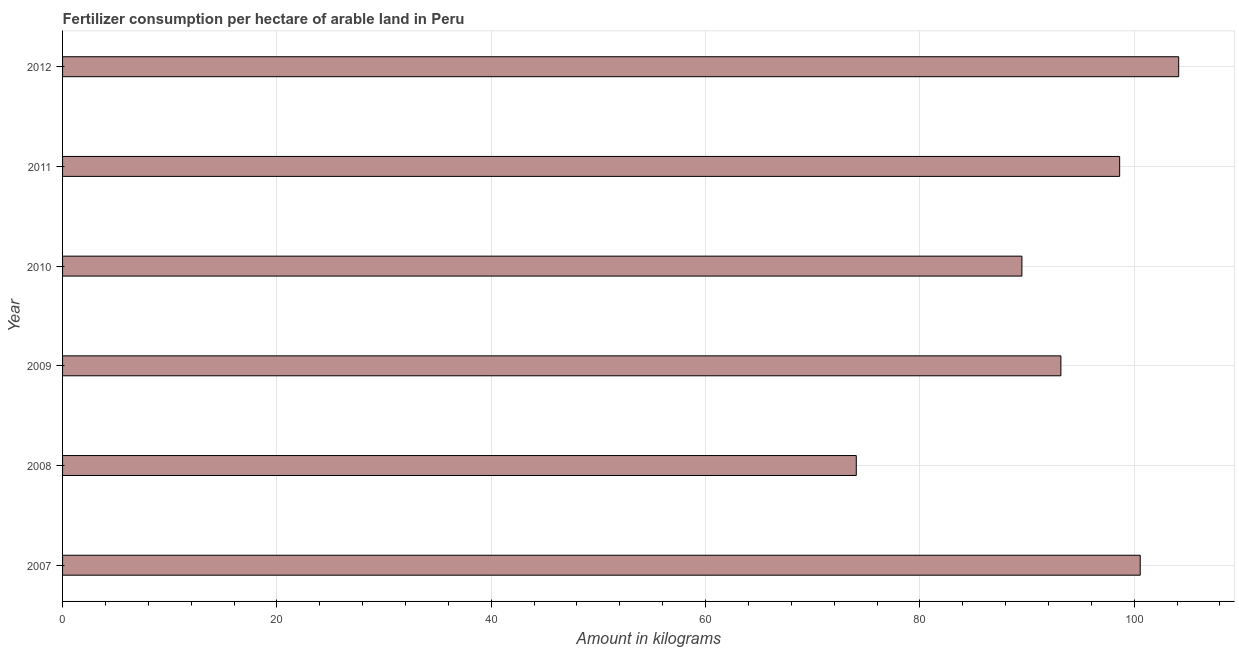Does the graph contain any zero values?
Offer a very short reply. No. Does the graph contain grids?
Offer a terse response. Yes. What is the title of the graph?
Ensure brevity in your answer.  Fertilizer consumption per hectare of arable land in Peru . What is the label or title of the X-axis?
Provide a succinct answer. Amount in kilograms. What is the amount of fertilizer consumption in 2011?
Offer a very short reply. 98.64. Across all years, what is the maximum amount of fertilizer consumption?
Your answer should be very brief. 104.15. Across all years, what is the minimum amount of fertilizer consumption?
Make the answer very short. 74.07. In which year was the amount of fertilizer consumption minimum?
Provide a succinct answer. 2008. What is the sum of the amount of fertilizer consumption?
Give a very brief answer. 560.1. What is the difference between the amount of fertilizer consumption in 2008 and 2010?
Offer a terse response. -15.46. What is the average amount of fertilizer consumption per year?
Your response must be concise. 93.35. What is the median amount of fertilizer consumption?
Ensure brevity in your answer.  95.9. What is the ratio of the amount of fertilizer consumption in 2008 to that in 2010?
Keep it short and to the point. 0.83. Is the amount of fertilizer consumption in 2010 less than that in 2011?
Your response must be concise. Yes. Is the difference between the amount of fertilizer consumption in 2008 and 2012 greater than the difference between any two years?
Your response must be concise. Yes. What is the difference between the highest and the second highest amount of fertilizer consumption?
Give a very brief answer. 3.59. What is the difference between the highest and the lowest amount of fertilizer consumption?
Your answer should be very brief. 30.09. In how many years, is the amount of fertilizer consumption greater than the average amount of fertilizer consumption taken over all years?
Your response must be concise. 3. Are all the bars in the graph horizontal?
Make the answer very short. Yes. What is the Amount in kilograms of 2007?
Offer a terse response. 100.56. What is the Amount in kilograms in 2008?
Keep it short and to the point. 74.07. What is the Amount in kilograms of 2009?
Provide a succinct answer. 93.16. What is the Amount in kilograms of 2010?
Give a very brief answer. 89.52. What is the Amount in kilograms in 2011?
Provide a succinct answer. 98.64. What is the Amount in kilograms in 2012?
Offer a very short reply. 104.15. What is the difference between the Amount in kilograms in 2007 and 2008?
Keep it short and to the point. 26.5. What is the difference between the Amount in kilograms in 2007 and 2009?
Offer a very short reply. 7.4. What is the difference between the Amount in kilograms in 2007 and 2010?
Offer a terse response. 11.04. What is the difference between the Amount in kilograms in 2007 and 2011?
Ensure brevity in your answer.  1.92. What is the difference between the Amount in kilograms in 2007 and 2012?
Ensure brevity in your answer.  -3.59. What is the difference between the Amount in kilograms in 2008 and 2009?
Make the answer very short. -19.09. What is the difference between the Amount in kilograms in 2008 and 2010?
Give a very brief answer. -15.46. What is the difference between the Amount in kilograms in 2008 and 2011?
Provide a short and direct response. -24.58. What is the difference between the Amount in kilograms in 2008 and 2012?
Provide a succinct answer. -30.09. What is the difference between the Amount in kilograms in 2009 and 2010?
Provide a succinct answer. 3.64. What is the difference between the Amount in kilograms in 2009 and 2011?
Your response must be concise. -5.48. What is the difference between the Amount in kilograms in 2009 and 2012?
Keep it short and to the point. -10.99. What is the difference between the Amount in kilograms in 2010 and 2011?
Offer a terse response. -9.12. What is the difference between the Amount in kilograms in 2010 and 2012?
Your answer should be very brief. -14.63. What is the difference between the Amount in kilograms in 2011 and 2012?
Keep it short and to the point. -5.51. What is the ratio of the Amount in kilograms in 2007 to that in 2008?
Your answer should be compact. 1.36. What is the ratio of the Amount in kilograms in 2007 to that in 2009?
Your answer should be compact. 1.08. What is the ratio of the Amount in kilograms in 2007 to that in 2010?
Make the answer very short. 1.12. What is the ratio of the Amount in kilograms in 2007 to that in 2011?
Provide a short and direct response. 1.02. What is the ratio of the Amount in kilograms in 2008 to that in 2009?
Provide a succinct answer. 0.8. What is the ratio of the Amount in kilograms in 2008 to that in 2010?
Your answer should be very brief. 0.83. What is the ratio of the Amount in kilograms in 2008 to that in 2011?
Keep it short and to the point. 0.75. What is the ratio of the Amount in kilograms in 2008 to that in 2012?
Offer a very short reply. 0.71. What is the ratio of the Amount in kilograms in 2009 to that in 2010?
Provide a succinct answer. 1.04. What is the ratio of the Amount in kilograms in 2009 to that in 2011?
Provide a short and direct response. 0.94. What is the ratio of the Amount in kilograms in 2009 to that in 2012?
Your answer should be very brief. 0.89. What is the ratio of the Amount in kilograms in 2010 to that in 2011?
Offer a very short reply. 0.91. What is the ratio of the Amount in kilograms in 2010 to that in 2012?
Provide a succinct answer. 0.86. What is the ratio of the Amount in kilograms in 2011 to that in 2012?
Keep it short and to the point. 0.95. 